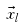Convert formula to latex. <formula><loc_0><loc_0><loc_500><loc_500>\vec { x } _ { l }</formula> 